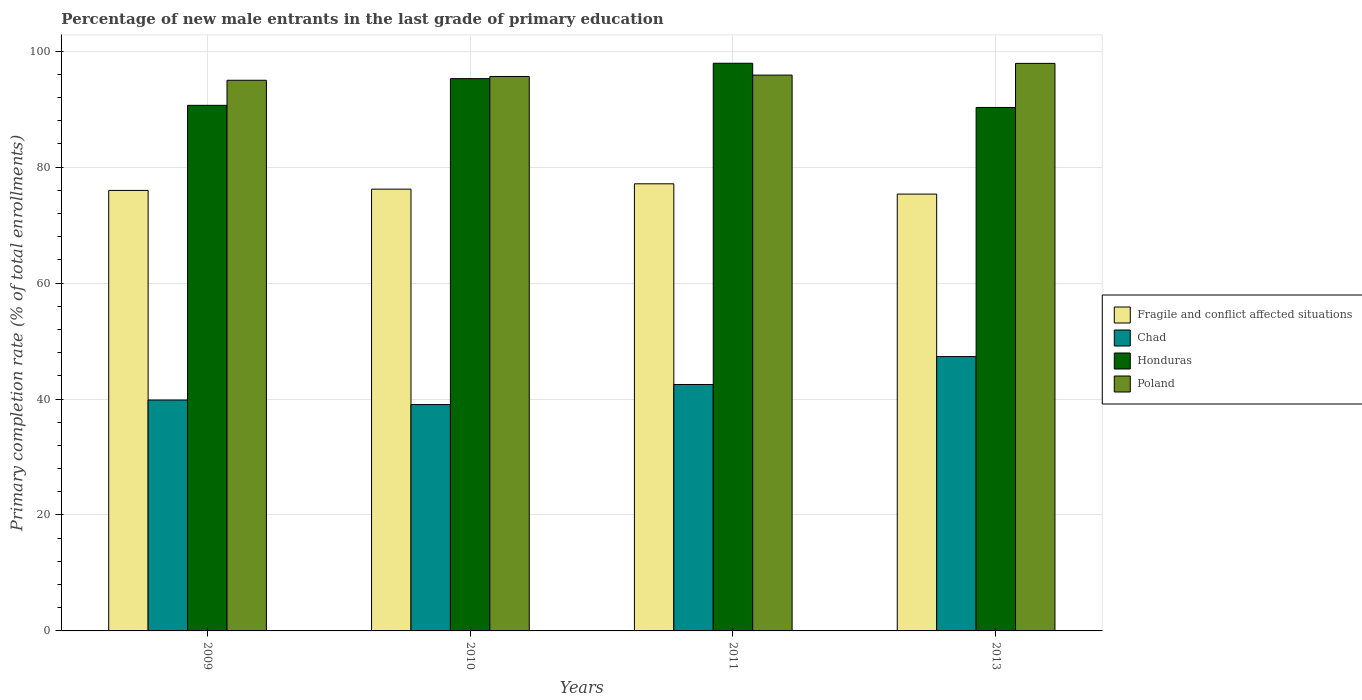Are the number of bars per tick equal to the number of legend labels?
Your response must be concise. Yes. In how many cases, is the number of bars for a given year not equal to the number of legend labels?
Offer a terse response. 0. What is the percentage of new male entrants in Chad in 2011?
Your answer should be compact. 42.5. Across all years, what is the maximum percentage of new male entrants in Fragile and conflict affected situations?
Offer a very short reply. 77.12. Across all years, what is the minimum percentage of new male entrants in Poland?
Make the answer very short. 94.98. What is the total percentage of new male entrants in Poland in the graph?
Your answer should be compact. 384.36. What is the difference between the percentage of new male entrants in Fragile and conflict affected situations in 2011 and that in 2013?
Your answer should be compact. 1.77. What is the difference between the percentage of new male entrants in Chad in 2010 and the percentage of new male entrants in Poland in 2009?
Ensure brevity in your answer.  -55.93. What is the average percentage of new male entrants in Fragile and conflict affected situations per year?
Provide a short and direct response. 76.16. In the year 2010, what is the difference between the percentage of new male entrants in Chad and percentage of new male entrants in Honduras?
Provide a succinct answer. -56.22. What is the ratio of the percentage of new male entrants in Chad in 2009 to that in 2013?
Keep it short and to the point. 0.84. What is the difference between the highest and the second highest percentage of new male entrants in Honduras?
Give a very brief answer. 2.65. What is the difference between the highest and the lowest percentage of new male entrants in Honduras?
Make the answer very short. 7.62. In how many years, is the percentage of new male entrants in Chad greater than the average percentage of new male entrants in Chad taken over all years?
Provide a short and direct response. 2. Is it the case that in every year, the sum of the percentage of new male entrants in Chad and percentage of new male entrants in Honduras is greater than the sum of percentage of new male entrants in Fragile and conflict affected situations and percentage of new male entrants in Poland?
Ensure brevity in your answer.  No. What does the 3rd bar from the left in 2010 represents?
Your answer should be compact. Honduras. What does the 3rd bar from the right in 2009 represents?
Provide a short and direct response. Chad. Is it the case that in every year, the sum of the percentage of new male entrants in Fragile and conflict affected situations and percentage of new male entrants in Chad is greater than the percentage of new male entrants in Honduras?
Your answer should be compact. Yes. How many bars are there?
Offer a terse response. 16. How many years are there in the graph?
Ensure brevity in your answer.  4. What is the title of the graph?
Your response must be concise. Percentage of new male entrants in the last grade of primary education. Does "Ghana" appear as one of the legend labels in the graph?
Offer a very short reply. No. What is the label or title of the X-axis?
Your response must be concise. Years. What is the label or title of the Y-axis?
Offer a terse response. Primary completion rate (% of total enrollments). What is the Primary completion rate (% of total enrollments) of Fragile and conflict affected situations in 2009?
Offer a very short reply. 75.98. What is the Primary completion rate (% of total enrollments) in Chad in 2009?
Provide a succinct answer. 39.83. What is the Primary completion rate (% of total enrollments) of Honduras in 2009?
Your response must be concise. 90.65. What is the Primary completion rate (% of total enrollments) of Poland in 2009?
Offer a very short reply. 94.98. What is the Primary completion rate (% of total enrollments) of Fragile and conflict affected situations in 2010?
Keep it short and to the point. 76.2. What is the Primary completion rate (% of total enrollments) in Chad in 2010?
Make the answer very short. 39.04. What is the Primary completion rate (% of total enrollments) of Honduras in 2010?
Give a very brief answer. 95.26. What is the Primary completion rate (% of total enrollments) of Poland in 2010?
Your answer should be very brief. 95.63. What is the Primary completion rate (% of total enrollments) of Fragile and conflict affected situations in 2011?
Offer a terse response. 77.12. What is the Primary completion rate (% of total enrollments) of Chad in 2011?
Your answer should be very brief. 42.5. What is the Primary completion rate (% of total enrollments) of Honduras in 2011?
Keep it short and to the point. 97.91. What is the Primary completion rate (% of total enrollments) of Poland in 2011?
Make the answer very short. 95.87. What is the Primary completion rate (% of total enrollments) in Fragile and conflict affected situations in 2013?
Make the answer very short. 75.34. What is the Primary completion rate (% of total enrollments) of Chad in 2013?
Offer a very short reply. 47.32. What is the Primary completion rate (% of total enrollments) in Honduras in 2013?
Ensure brevity in your answer.  90.28. What is the Primary completion rate (% of total enrollments) in Poland in 2013?
Make the answer very short. 97.89. Across all years, what is the maximum Primary completion rate (% of total enrollments) in Fragile and conflict affected situations?
Offer a very short reply. 77.12. Across all years, what is the maximum Primary completion rate (% of total enrollments) of Chad?
Your response must be concise. 47.32. Across all years, what is the maximum Primary completion rate (% of total enrollments) in Honduras?
Provide a short and direct response. 97.91. Across all years, what is the maximum Primary completion rate (% of total enrollments) of Poland?
Offer a terse response. 97.89. Across all years, what is the minimum Primary completion rate (% of total enrollments) in Fragile and conflict affected situations?
Provide a short and direct response. 75.34. Across all years, what is the minimum Primary completion rate (% of total enrollments) in Chad?
Provide a succinct answer. 39.04. Across all years, what is the minimum Primary completion rate (% of total enrollments) of Honduras?
Offer a terse response. 90.28. Across all years, what is the minimum Primary completion rate (% of total enrollments) of Poland?
Offer a very short reply. 94.98. What is the total Primary completion rate (% of total enrollments) in Fragile and conflict affected situations in the graph?
Provide a short and direct response. 304.64. What is the total Primary completion rate (% of total enrollments) of Chad in the graph?
Provide a short and direct response. 168.69. What is the total Primary completion rate (% of total enrollments) in Honduras in the graph?
Your answer should be compact. 374.1. What is the total Primary completion rate (% of total enrollments) of Poland in the graph?
Your answer should be very brief. 384.36. What is the difference between the Primary completion rate (% of total enrollments) in Fragile and conflict affected situations in 2009 and that in 2010?
Offer a very short reply. -0.22. What is the difference between the Primary completion rate (% of total enrollments) of Chad in 2009 and that in 2010?
Offer a very short reply. 0.78. What is the difference between the Primary completion rate (% of total enrollments) in Honduras in 2009 and that in 2010?
Give a very brief answer. -4.61. What is the difference between the Primary completion rate (% of total enrollments) in Poland in 2009 and that in 2010?
Provide a succinct answer. -0.65. What is the difference between the Primary completion rate (% of total enrollments) in Fragile and conflict affected situations in 2009 and that in 2011?
Provide a short and direct response. -1.14. What is the difference between the Primary completion rate (% of total enrollments) in Chad in 2009 and that in 2011?
Offer a terse response. -2.68. What is the difference between the Primary completion rate (% of total enrollments) of Honduras in 2009 and that in 2011?
Ensure brevity in your answer.  -7.26. What is the difference between the Primary completion rate (% of total enrollments) in Poland in 2009 and that in 2011?
Provide a succinct answer. -0.89. What is the difference between the Primary completion rate (% of total enrollments) of Fragile and conflict affected situations in 2009 and that in 2013?
Provide a succinct answer. 0.63. What is the difference between the Primary completion rate (% of total enrollments) in Chad in 2009 and that in 2013?
Your answer should be compact. -7.49. What is the difference between the Primary completion rate (% of total enrollments) in Honduras in 2009 and that in 2013?
Your answer should be compact. 0.37. What is the difference between the Primary completion rate (% of total enrollments) in Poland in 2009 and that in 2013?
Make the answer very short. -2.91. What is the difference between the Primary completion rate (% of total enrollments) in Fragile and conflict affected situations in 2010 and that in 2011?
Make the answer very short. -0.92. What is the difference between the Primary completion rate (% of total enrollments) in Chad in 2010 and that in 2011?
Make the answer very short. -3.46. What is the difference between the Primary completion rate (% of total enrollments) in Honduras in 2010 and that in 2011?
Offer a terse response. -2.65. What is the difference between the Primary completion rate (% of total enrollments) of Poland in 2010 and that in 2011?
Your response must be concise. -0.24. What is the difference between the Primary completion rate (% of total enrollments) of Fragile and conflict affected situations in 2010 and that in 2013?
Make the answer very short. 0.85. What is the difference between the Primary completion rate (% of total enrollments) of Chad in 2010 and that in 2013?
Offer a terse response. -8.28. What is the difference between the Primary completion rate (% of total enrollments) of Honduras in 2010 and that in 2013?
Provide a short and direct response. 4.97. What is the difference between the Primary completion rate (% of total enrollments) in Poland in 2010 and that in 2013?
Make the answer very short. -2.26. What is the difference between the Primary completion rate (% of total enrollments) of Fragile and conflict affected situations in 2011 and that in 2013?
Provide a short and direct response. 1.77. What is the difference between the Primary completion rate (% of total enrollments) of Chad in 2011 and that in 2013?
Ensure brevity in your answer.  -4.81. What is the difference between the Primary completion rate (% of total enrollments) of Honduras in 2011 and that in 2013?
Give a very brief answer. 7.62. What is the difference between the Primary completion rate (% of total enrollments) in Poland in 2011 and that in 2013?
Offer a terse response. -2.02. What is the difference between the Primary completion rate (% of total enrollments) of Fragile and conflict affected situations in 2009 and the Primary completion rate (% of total enrollments) of Chad in 2010?
Provide a succinct answer. 36.94. What is the difference between the Primary completion rate (% of total enrollments) of Fragile and conflict affected situations in 2009 and the Primary completion rate (% of total enrollments) of Honduras in 2010?
Ensure brevity in your answer.  -19.28. What is the difference between the Primary completion rate (% of total enrollments) of Fragile and conflict affected situations in 2009 and the Primary completion rate (% of total enrollments) of Poland in 2010?
Provide a short and direct response. -19.65. What is the difference between the Primary completion rate (% of total enrollments) in Chad in 2009 and the Primary completion rate (% of total enrollments) in Honduras in 2010?
Your answer should be compact. -55.43. What is the difference between the Primary completion rate (% of total enrollments) in Chad in 2009 and the Primary completion rate (% of total enrollments) in Poland in 2010?
Keep it short and to the point. -55.8. What is the difference between the Primary completion rate (% of total enrollments) in Honduras in 2009 and the Primary completion rate (% of total enrollments) in Poland in 2010?
Make the answer very short. -4.98. What is the difference between the Primary completion rate (% of total enrollments) in Fragile and conflict affected situations in 2009 and the Primary completion rate (% of total enrollments) in Chad in 2011?
Your response must be concise. 33.47. What is the difference between the Primary completion rate (% of total enrollments) of Fragile and conflict affected situations in 2009 and the Primary completion rate (% of total enrollments) of Honduras in 2011?
Your response must be concise. -21.93. What is the difference between the Primary completion rate (% of total enrollments) of Fragile and conflict affected situations in 2009 and the Primary completion rate (% of total enrollments) of Poland in 2011?
Offer a very short reply. -19.89. What is the difference between the Primary completion rate (% of total enrollments) in Chad in 2009 and the Primary completion rate (% of total enrollments) in Honduras in 2011?
Your response must be concise. -58.08. What is the difference between the Primary completion rate (% of total enrollments) of Chad in 2009 and the Primary completion rate (% of total enrollments) of Poland in 2011?
Ensure brevity in your answer.  -56.04. What is the difference between the Primary completion rate (% of total enrollments) of Honduras in 2009 and the Primary completion rate (% of total enrollments) of Poland in 2011?
Your answer should be very brief. -5.21. What is the difference between the Primary completion rate (% of total enrollments) of Fragile and conflict affected situations in 2009 and the Primary completion rate (% of total enrollments) of Chad in 2013?
Ensure brevity in your answer.  28.66. What is the difference between the Primary completion rate (% of total enrollments) in Fragile and conflict affected situations in 2009 and the Primary completion rate (% of total enrollments) in Honduras in 2013?
Keep it short and to the point. -14.31. What is the difference between the Primary completion rate (% of total enrollments) of Fragile and conflict affected situations in 2009 and the Primary completion rate (% of total enrollments) of Poland in 2013?
Your answer should be very brief. -21.91. What is the difference between the Primary completion rate (% of total enrollments) in Chad in 2009 and the Primary completion rate (% of total enrollments) in Honduras in 2013?
Offer a terse response. -50.46. What is the difference between the Primary completion rate (% of total enrollments) in Chad in 2009 and the Primary completion rate (% of total enrollments) in Poland in 2013?
Give a very brief answer. -58.06. What is the difference between the Primary completion rate (% of total enrollments) in Honduras in 2009 and the Primary completion rate (% of total enrollments) in Poland in 2013?
Provide a short and direct response. -7.24. What is the difference between the Primary completion rate (% of total enrollments) of Fragile and conflict affected situations in 2010 and the Primary completion rate (% of total enrollments) of Chad in 2011?
Your response must be concise. 33.69. What is the difference between the Primary completion rate (% of total enrollments) in Fragile and conflict affected situations in 2010 and the Primary completion rate (% of total enrollments) in Honduras in 2011?
Make the answer very short. -21.71. What is the difference between the Primary completion rate (% of total enrollments) of Fragile and conflict affected situations in 2010 and the Primary completion rate (% of total enrollments) of Poland in 2011?
Provide a succinct answer. -19.67. What is the difference between the Primary completion rate (% of total enrollments) in Chad in 2010 and the Primary completion rate (% of total enrollments) in Honduras in 2011?
Your answer should be compact. -58.87. What is the difference between the Primary completion rate (% of total enrollments) in Chad in 2010 and the Primary completion rate (% of total enrollments) in Poland in 2011?
Keep it short and to the point. -56.82. What is the difference between the Primary completion rate (% of total enrollments) in Honduras in 2010 and the Primary completion rate (% of total enrollments) in Poland in 2011?
Your response must be concise. -0.61. What is the difference between the Primary completion rate (% of total enrollments) of Fragile and conflict affected situations in 2010 and the Primary completion rate (% of total enrollments) of Chad in 2013?
Your answer should be compact. 28.88. What is the difference between the Primary completion rate (% of total enrollments) of Fragile and conflict affected situations in 2010 and the Primary completion rate (% of total enrollments) of Honduras in 2013?
Your answer should be very brief. -14.09. What is the difference between the Primary completion rate (% of total enrollments) of Fragile and conflict affected situations in 2010 and the Primary completion rate (% of total enrollments) of Poland in 2013?
Provide a succinct answer. -21.69. What is the difference between the Primary completion rate (% of total enrollments) of Chad in 2010 and the Primary completion rate (% of total enrollments) of Honduras in 2013?
Keep it short and to the point. -51.24. What is the difference between the Primary completion rate (% of total enrollments) in Chad in 2010 and the Primary completion rate (% of total enrollments) in Poland in 2013?
Make the answer very short. -58.85. What is the difference between the Primary completion rate (% of total enrollments) of Honduras in 2010 and the Primary completion rate (% of total enrollments) of Poland in 2013?
Offer a terse response. -2.63. What is the difference between the Primary completion rate (% of total enrollments) of Fragile and conflict affected situations in 2011 and the Primary completion rate (% of total enrollments) of Chad in 2013?
Provide a short and direct response. 29.8. What is the difference between the Primary completion rate (% of total enrollments) of Fragile and conflict affected situations in 2011 and the Primary completion rate (% of total enrollments) of Honduras in 2013?
Provide a succinct answer. -13.17. What is the difference between the Primary completion rate (% of total enrollments) of Fragile and conflict affected situations in 2011 and the Primary completion rate (% of total enrollments) of Poland in 2013?
Ensure brevity in your answer.  -20.77. What is the difference between the Primary completion rate (% of total enrollments) in Chad in 2011 and the Primary completion rate (% of total enrollments) in Honduras in 2013?
Provide a succinct answer. -47.78. What is the difference between the Primary completion rate (% of total enrollments) of Chad in 2011 and the Primary completion rate (% of total enrollments) of Poland in 2013?
Keep it short and to the point. -55.39. What is the difference between the Primary completion rate (% of total enrollments) of Honduras in 2011 and the Primary completion rate (% of total enrollments) of Poland in 2013?
Give a very brief answer. 0.02. What is the average Primary completion rate (% of total enrollments) of Fragile and conflict affected situations per year?
Provide a succinct answer. 76.16. What is the average Primary completion rate (% of total enrollments) of Chad per year?
Offer a very short reply. 42.17. What is the average Primary completion rate (% of total enrollments) of Honduras per year?
Make the answer very short. 93.53. What is the average Primary completion rate (% of total enrollments) in Poland per year?
Ensure brevity in your answer.  96.09. In the year 2009, what is the difference between the Primary completion rate (% of total enrollments) of Fragile and conflict affected situations and Primary completion rate (% of total enrollments) of Chad?
Offer a very short reply. 36.15. In the year 2009, what is the difference between the Primary completion rate (% of total enrollments) in Fragile and conflict affected situations and Primary completion rate (% of total enrollments) in Honduras?
Offer a terse response. -14.67. In the year 2009, what is the difference between the Primary completion rate (% of total enrollments) of Fragile and conflict affected situations and Primary completion rate (% of total enrollments) of Poland?
Provide a succinct answer. -19. In the year 2009, what is the difference between the Primary completion rate (% of total enrollments) of Chad and Primary completion rate (% of total enrollments) of Honduras?
Keep it short and to the point. -50.83. In the year 2009, what is the difference between the Primary completion rate (% of total enrollments) in Chad and Primary completion rate (% of total enrollments) in Poland?
Offer a terse response. -55.15. In the year 2009, what is the difference between the Primary completion rate (% of total enrollments) in Honduras and Primary completion rate (% of total enrollments) in Poland?
Keep it short and to the point. -4.32. In the year 2010, what is the difference between the Primary completion rate (% of total enrollments) of Fragile and conflict affected situations and Primary completion rate (% of total enrollments) of Chad?
Offer a terse response. 37.16. In the year 2010, what is the difference between the Primary completion rate (% of total enrollments) in Fragile and conflict affected situations and Primary completion rate (% of total enrollments) in Honduras?
Your answer should be very brief. -19.06. In the year 2010, what is the difference between the Primary completion rate (% of total enrollments) of Fragile and conflict affected situations and Primary completion rate (% of total enrollments) of Poland?
Make the answer very short. -19.43. In the year 2010, what is the difference between the Primary completion rate (% of total enrollments) of Chad and Primary completion rate (% of total enrollments) of Honduras?
Offer a very short reply. -56.22. In the year 2010, what is the difference between the Primary completion rate (% of total enrollments) in Chad and Primary completion rate (% of total enrollments) in Poland?
Provide a succinct answer. -56.59. In the year 2010, what is the difference between the Primary completion rate (% of total enrollments) in Honduras and Primary completion rate (% of total enrollments) in Poland?
Offer a terse response. -0.37. In the year 2011, what is the difference between the Primary completion rate (% of total enrollments) in Fragile and conflict affected situations and Primary completion rate (% of total enrollments) in Chad?
Offer a terse response. 34.61. In the year 2011, what is the difference between the Primary completion rate (% of total enrollments) in Fragile and conflict affected situations and Primary completion rate (% of total enrollments) in Honduras?
Ensure brevity in your answer.  -20.79. In the year 2011, what is the difference between the Primary completion rate (% of total enrollments) in Fragile and conflict affected situations and Primary completion rate (% of total enrollments) in Poland?
Ensure brevity in your answer.  -18.75. In the year 2011, what is the difference between the Primary completion rate (% of total enrollments) in Chad and Primary completion rate (% of total enrollments) in Honduras?
Make the answer very short. -55.41. In the year 2011, what is the difference between the Primary completion rate (% of total enrollments) of Chad and Primary completion rate (% of total enrollments) of Poland?
Offer a very short reply. -53.36. In the year 2011, what is the difference between the Primary completion rate (% of total enrollments) in Honduras and Primary completion rate (% of total enrollments) in Poland?
Give a very brief answer. 2.04. In the year 2013, what is the difference between the Primary completion rate (% of total enrollments) of Fragile and conflict affected situations and Primary completion rate (% of total enrollments) of Chad?
Give a very brief answer. 28.03. In the year 2013, what is the difference between the Primary completion rate (% of total enrollments) in Fragile and conflict affected situations and Primary completion rate (% of total enrollments) in Honduras?
Offer a very short reply. -14.94. In the year 2013, what is the difference between the Primary completion rate (% of total enrollments) in Fragile and conflict affected situations and Primary completion rate (% of total enrollments) in Poland?
Keep it short and to the point. -22.55. In the year 2013, what is the difference between the Primary completion rate (% of total enrollments) of Chad and Primary completion rate (% of total enrollments) of Honduras?
Your response must be concise. -42.97. In the year 2013, what is the difference between the Primary completion rate (% of total enrollments) in Chad and Primary completion rate (% of total enrollments) in Poland?
Offer a very short reply. -50.57. In the year 2013, what is the difference between the Primary completion rate (% of total enrollments) of Honduras and Primary completion rate (% of total enrollments) of Poland?
Provide a succinct answer. -7.6. What is the ratio of the Primary completion rate (% of total enrollments) in Chad in 2009 to that in 2010?
Make the answer very short. 1.02. What is the ratio of the Primary completion rate (% of total enrollments) of Honduras in 2009 to that in 2010?
Your answer should be compact. 0.95. What is the ratio of the Primary completion rate (% of total enrollments) of Poland in 2009 to that in 2010?
Your answer should be very brief. 0.99. What is the ratio of the Primary completion rate (% of total enrollments) of Fragile and conflict affected situations in 2009 to that in 2011?
Give a very brief answer. 0.99. What is the ratio of the Primary completion rate (% of total enrollments) of Chad in 2009 to that in 2011?
Make the answer very short. 0.94. What is the ratio of the Primary completion rate (% of total enrollments) in Honduras in 2009 to that in 2011?
Your response must be concise. 0.93. What is the ratio of the Primary completion rate (% of total enrollments) of Poland in 2009 to that in 2011?
Your answer should be compact. 0.99. What is the ratio of the Primary completion rate (% of total enrollments) in Fragile and conflict affected situations in 2009 to that in 2013?
Offer a terse response. 1.01. What is the ratio of the Primary completion rate (% of total enrollments) of Chad in 2009 to that in 2013?
Your answer should be very brief. 0.84. What is the ratio of the Primary completion rate (% of total enrollments) in Poland in 2009 to that in 2013?
Provide a succinct answer. 0.97. What is the ratio of the Primary completion rate (% of total enrollments) in Fragile and conflict affected situations in 2010 to that in 2011?
Offer a very short reply. 0.99. What is the ratio of the Primary completion rate (% of total enrollments) in Chad in 2010 to that in 2011?
Ensure brevity in your answer.  0.92. What is the ratio of the Primary completion rate (% of total enrollments) of Honduras in 2010 to that in 2011?
Your answer should be compact. 0.97. What is the ratio of the Primary completion rate (% of total enrollments) in Poland in 2010 to that in 2011?
Your answer should be compact. 1. What is the ratio of the Primary completion rate (% of total enrollments) in Fragile and conflict affected situations in 2010 to that in 2013?
Provide a succinct answer. 1.01. What is the ratio of the Primary completion rate (% of total enrollments) in Chad in 2010 to that in 2013?
Ensure brevity in your answer.  0.83. What is the ratio of the Primary completion rate (% of total enrollments) of Honduras in 2010 to that in 2013?
Provide a short and direct response. 1.06. What is the ratio of the Primary completion rate (% of total enrollments) in Poland in 2010 to that in 2013?
Make the answer very short. 0.98. What is the ratio of the Primary completion rate (% of total enrollments) of Fragile and conflict affected situations in 2011 to that in 2013?
Your answer should be compact. 1.02. What is the ratio of the Primary completion rate (% of total enrollments) in Chad in 2011 to that in 2013?
Provide a short and direct response. 0.9. What is the ratio of the Primary completion rate (% of total enrollments) in Honduras in 2011 to that in 2013?
Offer a very short reply. 1.08. What is the ratio of the Primary completion rate (% of total enrollments) in Poland in 2011 to that in 2013?
Your answer should be very brief. 0.98. What is the difference between the highest and the second highest Primary completion rate (% of total enrollments) in Fragile and conflict affected situations?
Make the answer very short. 0.92. What is the difference between the highest and the second highest Primary completion rate (% of total enrollments) in Chad?
Your response must be concise. 4.81. What is the difference between the highest and the second highest Primary completion rate (% of total enrollments) in Honduras?
Give a very brief answer. 2.65. What is the difference between the highest and the second highest Primary completion rate (% of total enrollments) in Poland?
Give a very brief answer. 2.02. What is the difference between the highest and the lowest Primary completion rate (% of total enrollments) in Fragile and conflict affected situations?
Your answer should be very brief. 1.77. What is the difference between the highest and the lowest Primary completion rate (% of total enrollments) in Chad?
Your answer should be very brief. 8.28. What is the difference between the highest and the lowest Primary completion rate (% of total enrollments) in Honduras?
Your answer should be compact. 7.62. What is the difference between the highest and the lowest Primary completion rate (% of total enrollments) of Poland?
Your response must be concise. 2.91. 